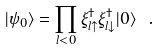<formula> <loc_0><loc_0><loc_500><loc_500>| \psi _ { 0 } \rangle = \prod _ { l < 0 } \xi ^ { \dagger } _ { l \uparrow } \xi ^ { \dagger } _ { l \downarrow } | 0 \rangle \ .</formula> 